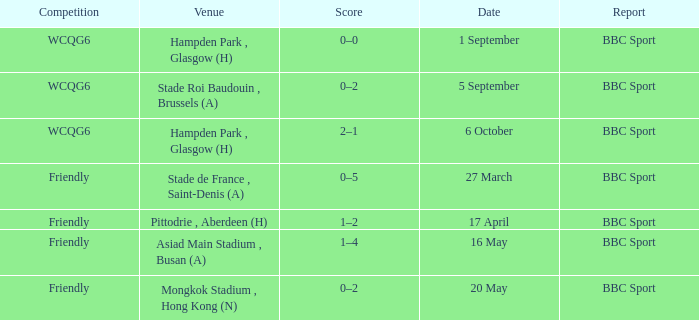What was the score of the game on 1 september? 0–0. 